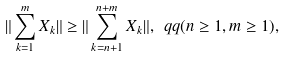<formula> <loc_0><loc_0><loc_500><loc_500>\| \sum _ { k = 1 } ^ { m } X _ { k } \| \geq \| \sum _ { k = n + 1 } ^ { n + m } X _ { k } \| , \ q q ( n \geq 1 , m \geq 1 ) ,</formula> 